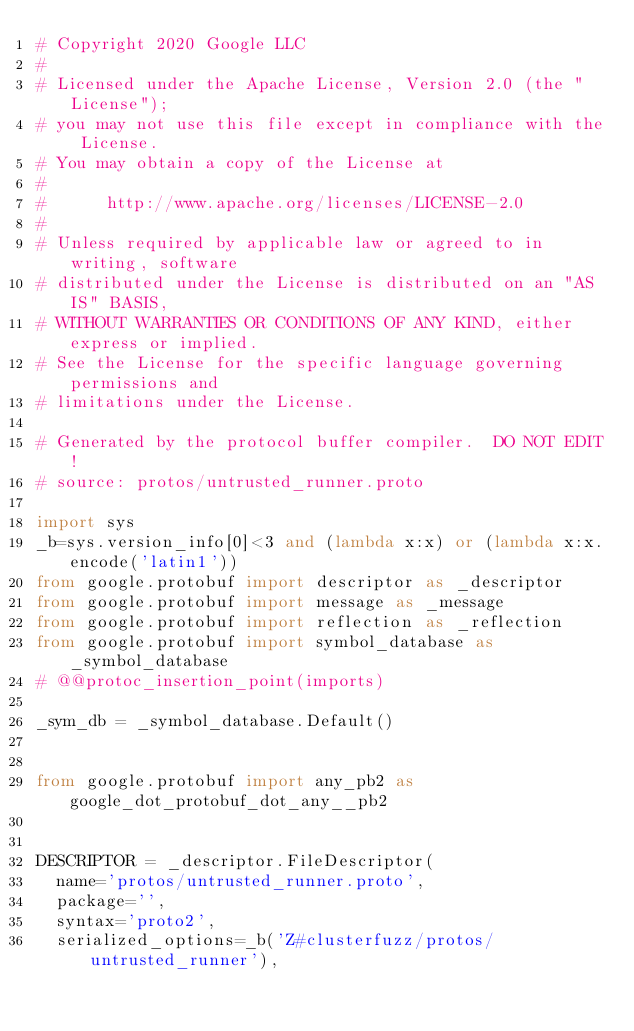Convert code to text. <code><loc_0><loc_0><loc_500><loc_500><_Python_># Copyright 2020 Google LLC
#
# Licensed under the Apache License, Version 2.0 (the "License");
# you may not use this file except in compliance with the License.
# You may obtain a copy of the License at
#
#      http://www.apache.org/licenses/LICENSE-2.0
#
# Unless required by applicable law or agreed to in writing, software
# distributed under the License is distributed on an "AS IS" BASIS,
# WITHOUT WARRANTIES OR CONDITIONS OF ANY KIND, either express or implied.
# See the License for the specific language governing permissions and
# limitations under the License.

# Generated by the protocol buffer compiler.  DO NOT EDIT!
# source: protos/untrusted_runner.proto

import sys
_b=sys.version_info[0]<3 and (lambda x:x) or (lambda x:x.encode('latin1'))
from google.protobuf import descriptor as _descriptor
from google.protobuf import message as _message
from google.protobuf import reflection as _reflection
from google.protobuf import symbol_database as _symbol_database
# @@protoc_insertion_point(imports)

_sym_db = _symbol_database.Default()


from google.protobuf import any_pb2 as google_dot_protobuf_dot_any__pb2


DESCRIPTOR = _descriptor.FileDescriptor(
  name='protos/untrusted_runner.proto',
  package='',
  syntax='proto2',
  serialized_options=_b('Z#clusterfuzz/protos/untrusted_runner'),</code> 